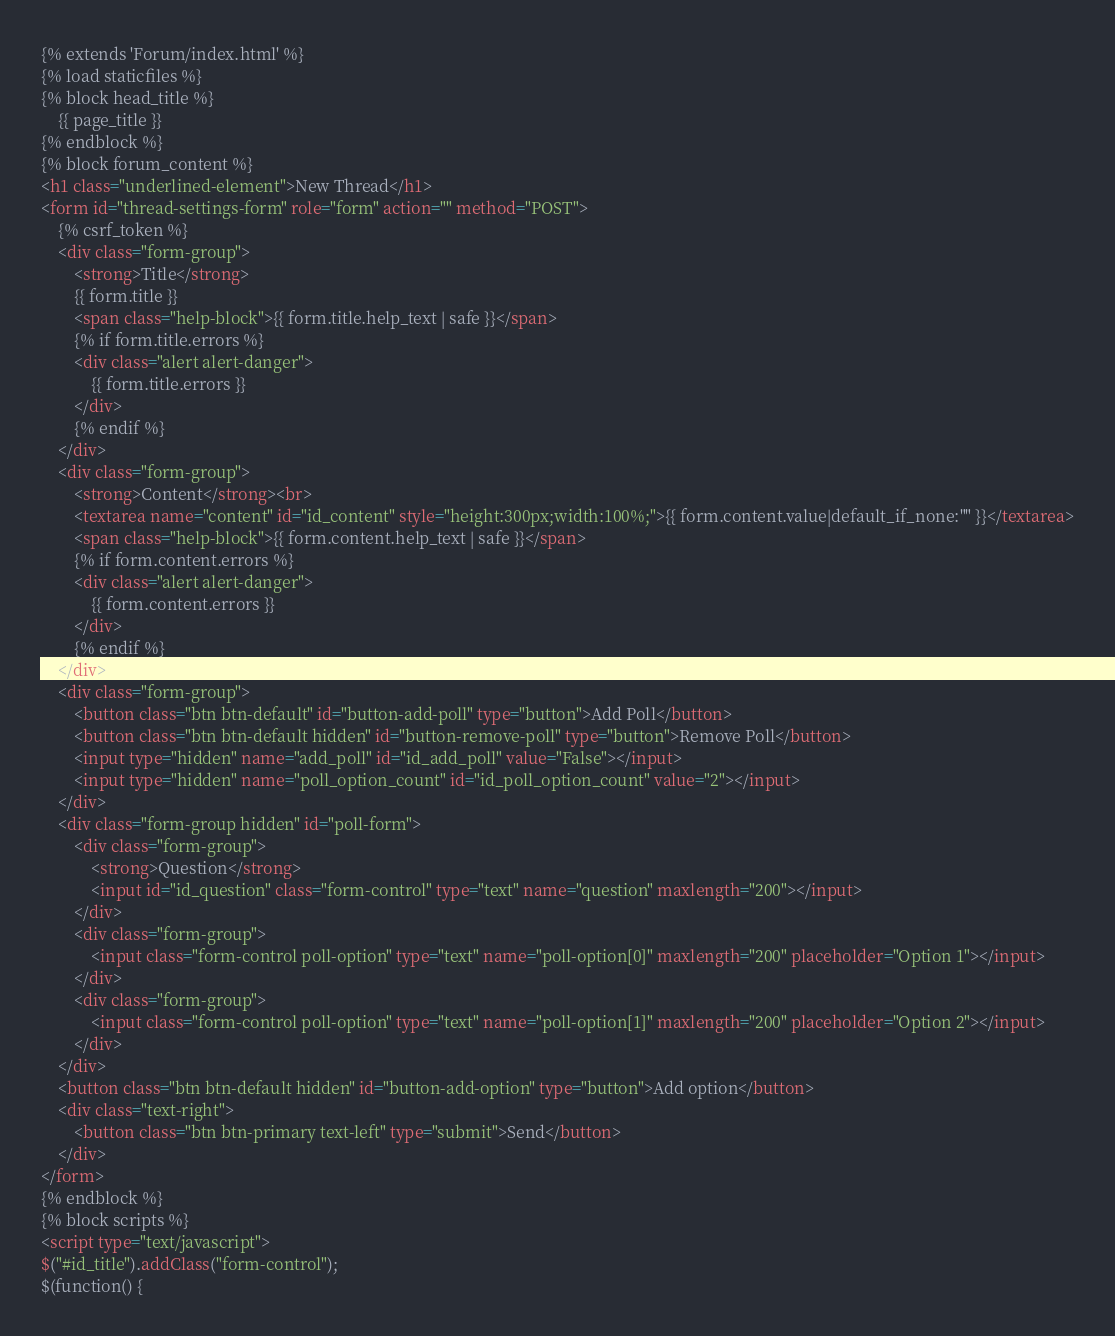Convert code to text. <code><loc_0><loc_0><loc_500><loc_500><_HTML_>{% extends 'Forum/index.html' %}
{% load staticfiles %}
{% block head_title %}
	{{ page_title }}
{% endblock %}
{% block forum_content %}
<h1 class="underlined-element">New Thread</h1>
<form id="thread-settings-form" role="form" action="" method="POST">
	{% csrf_token %}
	<div class="form-group">
		<strong>Title</strong>
		{{ form.title }}
		<span class="help-block">{{ form.title.help_text | safe }}</span>
		{% if form.title.errors %}
		<div class="alert alert-danger">
			{{ form.title.errors }}
		</div>
		{% endif %}
	</div>
	<div class="form-group">
		<strong>Content</strong><br>
		<textarea name="content" id="id_content" style="height:300px;width:100%;">{{ form.content.value|default_if_none:"" }}</textarea>
		<span class="help-block">{{ form.content.help_text | safe }}</span>
		{% if form.content.errors %}
		<div class="alert alert-danger">
			{{ form.content.errors }}
		</div>
		{% endif %}
	</div>
	<div class="form-group">
		<button class="btn btn-default" id="button-add-poll" type="button">Add Poll</button>
		<button class="btn btn-default hidden" id="button-remove-poll" type="button">Remove Poll</button>
		<input type="hidden" name="add_poll" id="id_add_poll" value="False"></input>
		<input type="hidden" name="poll_option_count" id="id_poll_option_count" value="2"></input>
	</div>
	<div class="form-group hidden" id="poll-form">
		<div class="form-group">
			<strong>Question</strong>
			<input id="id_question" class="form-control" type="text" name="question" maxlength="200"></input>
		</div>
		<div class="form-group">
			<input class="form-control poll-option" type="text" name="poll-option[0]" maxlength="200" placeholder="Option 1"></input>
		</div>
		<div class="form-group">
			<input class="form-control poll-option" type="text" name="poll-option[1]" maxlength="200" placeholder="Option 2"></input>
		</div>
	</div>
	<button class="btn btn-default hidden" id="button-add-option" type="button">Add option</button>
	<div class="text-right">
		<button class="btn btn-primary text-left" type="submit">Send</button>
	</div>
</form>
{% endblock %}
{% block scripts %}
<script type="text/javascript">
$("#id_title").addClass("form-control");
$(function() {</code> 